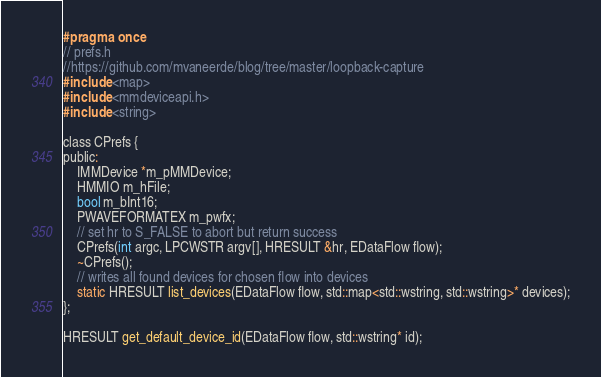<code> <loc_0><loc_0><loc_500><loc_500><_C_>#pragma once
// prefs.h
//https://github.com/mvaneerde/blog/tree/master/loopback-capture
#include <map>
#include <mmdeviceapi.h>
#include <string>

class CPrefs {
public:
	IMMDevice *m_pMMDevice;
	HMMIO m_hFile;
	bool m_bInt16;
	PWAVEFORMATEX m_pwfx;
	// set hr to S_FALSE to abort but return success
	CPrefs(int argc, LPCWSTR argv[], HRESULT &hr, EDataFlow flow);
	~CPrefs();
	// writes all found devices for chosen flow into devices
	static HRESULT list_devices(EDataFlow flow, std::map<std::wstring, std::wstring>* devices);
};

HRESULT get_default_device_id(EDataFlow flow, std::wstring* id);</code> 